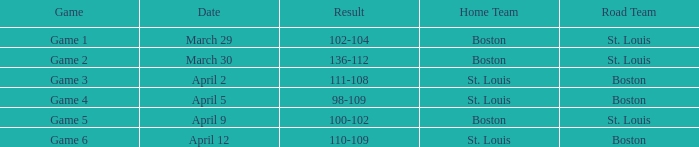What is the Game number on March 30? Game 2. 